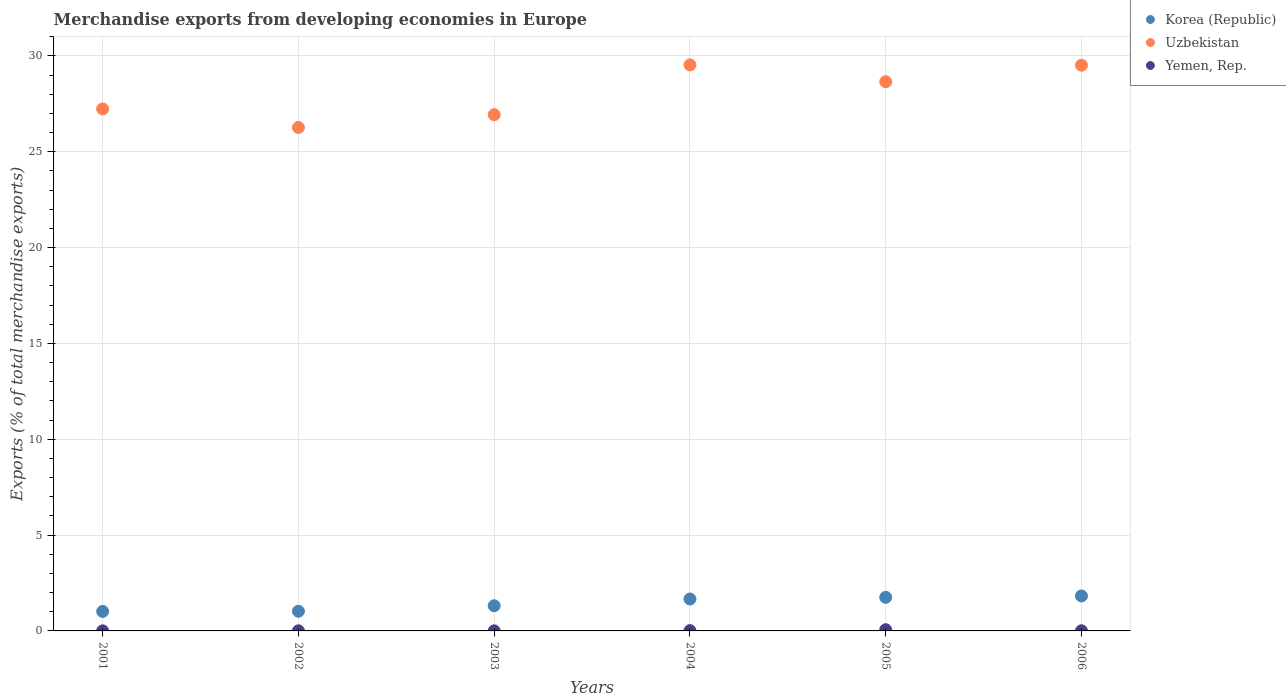How many different coloured dotlines are there?
Keep it short and to the point. 3. What is the percentage of total merchandise exports in Uzbekistan in 2004?
Offer a terse response. 29.53. Across all years, what is the maximum percentage of total merchandise exports in Korea (Republic)?
Provide a succinct answer. 1.82. Across all years, what is the minimum percentage of total merchandise exports in Yemen, Rep.?
Provide a short and direct response. 0. In which year was the percentage of total merchandise exports in Korea (Republic) maximum?
Ensure brevity in your answer.  2006. In which year was the percentage of total merchandise exports in Korea (Republic) minimum?
Offer a terse response. 2001. What is the total percentage of total merchandise exports in Korea (Republic) in the graph?
Keep it short and to the point. 8.6. What is the difference between the percentage of total merchandise exports in Uzbekistan in 2001 and that in 2006?
Offer a very short reply. -2.28. What is the difference between the percentage of total merchandise exports in Uzbekistan in 2004 and the percentage of total merchandise exports in Korea (Republic) in 2001?
Your response must be concise. 28.51. What is the average percentage of total merchandise exports in Korea (Republic) per year?
Your answer should be compact. 1.43. In the year 2002, what is the difference between the percentage of total merchandise exports in Yemen, Rep. and percentage of total merchandise exports in Uzbekistan?
Ensure brevity in your answer.  -26.26. In how many years, is the percentage of total merchandise exports in Uzbekistan greater than 11 %?
Your response must be concise. 6. What is the ratio of the percentage of total merchandise exports in Yemen, Rep. in 2003 to that in 2004?
Provide a short and direct response. 0.27. What is the difference between the highest and the second highest percentage of total merchandise exports in Yemen, Rep.?
Provide a short and direct response. 0.05. What is the difference between the highest and the lowest percentage of total merchandise exports in Uzbekistan?
Make the answer very short. 3.27. Is the sum of the percentage of total merchandise exports in Uzbekistan in 2005 and 2006 greater than the maximum percentage of total merchandise exports in Korea (Republic) across all years?
Give a very brief answer. Yes. Is it the case that in every year, the sum of the percentage of total merchandise exports in Korea (Republic) and percentage of total merchandise exports in Uzbekistan  is greater than the percentage of total merchandise exports in Yemen, Rep.?
Make the answer very short. Yes. Does the percentage of total merchandise exports in Yemen, Rep. monotonically increase over the years?
Your answer should be very brief. No. Is the percentage of total merchandise exports in Yemen, Rep. strictly greater than the percentage of total merchandise exports in Uzbekistan over the years?
Offer a very short reply. No. Is the percentage of total merchandise exports in Yemen, Rep. strictly less than the percentage of total merchandise exports in Uzbekistan over the years?
Offer a terse response. Yes. How many dotlines are there?
Provide a succinct answer. 3. How many years are there in the graph?
Offer a very short reply. 6. Are the values on the major ticks of Y-axis written in scientific E-notation?
Keep it short and to the point. No. Does the graph contain any zero values?
Offer a very short reply. No. What is the title of the graph?
Keep it short and to the point. Merchandise exports from developing economies in Europe. What is the label or title of the Y-axis?
Give a very brief answer. Exports (% of total merchandise exports). What is the Exports (% of total merchandise exports) in Korea (Republic) in 2001?
Make the answer very short. 1.02. What is the Exports (% of total merchandise exports) of Uzbekistan in 2001?
Your answer should be compact. 27.23. What is the Exports (% of total merchandise exports) of Yemen, Rep. in 2001?
Keep it short and to the point. 0. What is the Exports (% of total merchandise exports) of Korea (Republic) in 2002?
Provide a short and direct response. 1.03. What is the Exports (% of total merchandise exports) in Uzbekistan in 2002?
Make the answer very short. 26.26. What is the Exports (% of total merchandise exports) in Yemen, Rep. in 2002?
Provide a succinct answer. 0.01. What is the Exports (% of total merchandise exports) of Korea (Republic) in 2003?
Your answer should be very brief. 1.31. What is the Exports (% of total merchandise exports) of Uzbekistan in 2003?
Make the answer very short. 26.93. What is the Exports (% of total merchandise exports) in Yemen, Rep. in 2003?
Offer a very short reply. 0. What is the Exports (% of total merchandise exports) in Korea (Republic) in 2004?
Ensure brevity in your answer.  1.67. What is the Exports (% of total merchandise exports) of Uzbekistan in 2004?
Provide a short and direct response. 29.53. What is the Exports (% of total merchandise exports) in Yemen, Rep. in 2004?
Make the answer very short. 0.02. What is the Exports (% of total merchandise exports) in Korea (Republic) in 2005?
Make the answer very short. 1.75. What is the Exports (% of total merchandise exports) of Uzbekistan in 2005?
Offer a terse response. 28.65. What is the Exports (% of total merchandise exports) of Yemen, Rep. in 2005?
Keep it short and to the point. 0.06. What is the Exports (% of total merchandise exports) of Korea (Republic) in 2006?
Offer a terse response. 1.82. What is the Exports (% of total merchandise exports) of Uzbekistan in 2006?
Offer a terse response. 29.51. What is the Exports (% of total merchandise exports) of Yemen, Rep. in 2006?
Your answer should be compact. 0.01. Across all years, what is the maximum Exports (% of total merchandise exports) of Korea (Republic)?
Your answer should be very brief. 1.82. Across all years, what is the maximum Exports (% of total merchandise exports) in Uzbekistan?
Keep it short and to the point. 29.53. Across all years, what is the maximum Exports (% of total merchandise exports) in Yemen, Rep.?
Your answer should be very brief. 0.06. Across all years, what is the minimum Exports (% of total merchandise exports) of Korea (Republic)?
Keep it short and to the point. 1.02. Across all years, what is the minimum Exports (% of total merchandise exports) in Uzbekistan?
Your response must be concise. 26.26. Across all years, what is the minimum Exports (% of total merchandise exports) of Yemen, Rep.?
Provide a short and direct response. 0. What is the total Exports (% of total merchandise exports) of Korea (Republic) in the graph?
Make the answer very short. 8.6. What is the total Exports (% of total merchandise exports) in Uzbekistan in the graph?
Your response must be concise. 168.12. What is the total Exports (% of total merchandise exports) in Yemen, Rep. in the graph?
Ensure brevity in your answer.  0.1. What is the difference between the Exports (% of total merchandise exports) in Korea (Republic) in 2001 and that in 2002?
Ensure brevity in your answer.  -0.01. What is the difference between the Exports (% of total merchandise exports) of Uzbekistan in 2001 and that in 2002?
Offer a terse response. 0.97. What is the difference between the Exports (% of total merchandise exports) in Yemen, Rep. in 2001 and that in 2002?
Provide a short and direct response. -0. What is the difference between the Exports (% of total merchandise exports) in Korea (Republic) in 2001 and that in 2003?
Make the answer very short. -0.29. What is the difference between the Exports (% of total merchandise exports) in Uzbekistan in 2001 and that in 2003?
Your answer should be very brief. 0.3. What is the difference between the Exports (% of total merchandise exports) in Yemen, Rep. in 2001 and that in 2003?
Your answer should be very brief. -0. What is the difference between the Exports (% of total merchandise exports) of Korea (Republic) in 2001 and that in 2004?
Make the answer very short. -0.65. What is the difference between the Exports (% of total merchandise exports) in Uzbekistan in 2001 and that in 2004?
Your answer should be compact. -2.3. What is the difference between the Exports (% of total merchandise exports) of Yemen, Rep. in 2001 and that in 2004?
Offer a terse response. -0.01. What is the difference between the Exports (% of total merchandise exports) of Korea (Republic) in 2001 and that in 2005?
Keep it short and to the point. -0.73. What is the difference between the Exports (% of total merchandise exports) of Uzbekistan in 2001 and that in 2005?
Your answer should be very brief. -1.42. What is the difference between the Exports (% of total merchandise exports) in Yemen, Rep. in 2001 and that in 2005?
Your answer should be compact. -0.06. What is the difference between the Exports (% of total merchandise exports) of Korea (Republic) in 2001 and that in 2006?
Your answer should be very brief. -0.81. What is the difference between the Exports (% of total merchandise exports) in Uzbekistan in 2001 and that in 2006?
Offer a very short reply. -2.28. What is the difference between the Exports (% of total merchandise exports) in Yemen, Rep. in 2001 and that in 2006?
Your response must be concise. -0. What is the difference between the Exports (% of total merchandise exports) in Korea (Republic) in 2002 and that in 2003?
Provide a short and direct response. -0.29. What is the difference between the Exports (% of total merchandise exports) in Uzbekistan in 2002 and that in 2003?
Provide a succinct answer. -0.67. What is the difference between the Exports (% of total merchandise exports) in Yemen, Rep. in 2002 and that in 2003?
Make the answer very short. 0. What is the difference between the Exports (% of total merchandise exports) of Korea (Republic) in 2002 and that in 2004?
Offer a terse response. -0.64. What is the difference between the Exports (% of total merchandise exports) in Uzbekistan in 2002 and that in 2004?
Your answer should be compact. -3.27. What is the difference between the Exports (% of total merchandise exports) of Yemen, Rep. in 2002 and that in 2004?
Your response must be concise. -0.01. What is the difference between the Exports (% of total merchandise exports) in Korea (Republic) in 2002 and that in 2005?
Make the answer very short. -0.73. What is the difference between the Exports (% of total merchandise exports) of Uzbekistan in 2002 and that in 2005?
Keep it short and to the point. -2.39. What is the difference between the Exports (% of total merchandise exports) of Yemen, Rep. in 2002 and that in 2005?
Provide a succinct answer. -0.06. What is the difference between the Exports (% of total merchandise exports) of Korea (Republic) in 2002 and that in 2006?
Give a very brief answer. -0.8. What is the difference between the Exports (% of total merchandise exports) of Uzbekistan in 2002 and that in 2006?
Offer a very short reply. -3.25. What is the difference between the Exports (% of total merchandise exports) of Yemen, Rep. in 2002 and that in 2006?
Your response must be concise. -0. What is the difference between the Exports (% of total merchandise exports) of Korea (Republic) in 2003 and that in 2004?
Your answer should be compact. -0.35. What is the difference between the Exports (% of total merchandise exports) of Uzbekistan in 2003 and that in 2004?
Ensure brevity in your answer.  -2.6. What is the difference between the Exports (% of total merchandise exports) of Yemen, Rep. in 2003 and that in 2004?
Your answer should be very brief. -0.01. What is the difference between the Exports (% of total merchandise exports) in Korea (Republic) in 2003 and that in 2005?
Make the answer very short. -0.44. What is the difference between the Exports (% of total merchandise exports) in Uzbekistan in 2003 and that in 2005?
Offer a terse response. -1.72. What is the difference between the Exports (% of total merchandise exports) of Yemen, Rep. in 2003 and that in 2005?
Ensure brevity in your answer.  -0.06. What is the difference between the Exports (% of total merchandise exports) in Korea (Republic) in 2003 and that in 2006?
Provide a succinct answer. -0.51. What is the difference between the Exports (% of total merchandise exports) in Uzbekistan in 2003 and that in 2006?
Give a very brief answer. -2.58. What is the difference between the Exports (% of total merchandise exports) in Yemen, Rep. in 2003 and that in 2006?
Your response must be concise. -0. What is the difference between the Exports (% of total merchandise exports) in Korea (Republic) in 2004 and that in 2005?
Your answer should be compact. -0.09. What is the difference between the Exports (% of total merchandise exports) of Uzbekistan in 2004 and that in 2005?
Make the answer very short. 0.88. What is the difference between the Exports (% of total merchandise exports) of Yemen, Rep. in 2004 and that in 2005?
Make the answer very short. -0.05. What is the difference between the Exports (% of total merchandise exports) of Korea (Republic) in 2004 and that in 2006?
Keep it short and to the point. -0.16. What is the difference between the Exports (% of total merchandise exports) in Uzbekistan in 2004 and that in 2006?
Your response must be concise. 0.02. What is the difference between the Exports (% of total merchandise exports) in Yemen, Rep. in 2004 and that in 2006?
Make the answer very short. 0.01. What is the difference between the Exports (% of total merchandise exports) in Korea (Republic) in 2005 and that in 2006?
Your answer should be very brief. -0.07. What is the difference between the Exports (% of total merchandise exports) of Uzbekistan in 2005 and that in 2006?
Keep it short and to the point. -0.86. What is the difference between the Exports (% of total merchandise exports) in Yemen, Rep. in 2005 and that in 2006?
Make the answer very short. 0.05. What is the difference between the Exports (% of total merchandise exports) in Korea (Republic) in 2001 and the Exports (% of total merchandise exports) in Uzbekistan in 2002?
Your response must be concise. -25.25. What is the difference between the Exports (% of total merchandise exports) of Korea (Republic) in 2001 and the Exports (% of total merchandise exports) of Yemen, Rep. in 2002?
Keep it short and to the point. 1.01. What is the difference between the Exports (% of total merchandise exports) in Uzbekistan in 2001 and the Exports (% of total merchandise exports) in Yemen, Rep. in 2002?
Offer a very short reply. 27.23. What is the difference between the Exports (% of total merchandise exports) in Korea (Republic) in 2001 and the Exports (% of total merchandise exports) in Uzbekistan in 2003?
Your answer should be very brief. -25.91. What is the difference between the Exports (% of total merchandise exports) in Korea (Republic) in 2001 and the Exports (% of total merchandise exports) in Yemen, Rep. in 2003?
Your answer should be very brief. 1.01. What is the difference between the Exports (% of total merchandise exports) of Uzbekistan in 2001 and the Exports (% of total merchandise exports) of Yemen, Rep. in 2003?
Provide a short and direct response. 27.23. What is the difference between the Exports (% of total merchandise exports) of Korea (Republic) in 2001 and the Exports (% of total merchandise exports) of Uzbekistan in 2004?
Keep it short and to the point. -28.51. What is the difference between the Exports (% of total merchandise exports) of Korea (Republic) in 2001 and the Exports (% of total merchandise exports) of Yemen, Rep. in 2004?
Your response must be concise. 1. What is the difference between the Exports (% of total merchandise exports) of Uzbekistan in 2001 and the Exports (% of total merchandise exports) of Yemen, Rep. in 2004?
Your answer should be very brief. 27.22. What is the difference between the Exports (% of total merchandise exports) in Korea (Republic) in 2001 and the Exports (% of total merchandise exports) in Uzbekistan in 2005?
Keep it short and to the point. -27.63. What is the difference between the Exports (% of total merchandise exports) of Korea (Republic) in 2001 and the Exports (% of total merchandise exports) of Yemen, Rep. in 2005?
Give a very brief answer. 0.95. What is the difference between the Exports (% of total merchandise exports) in Uzbekistan in 2001 and the Exports (% of total merchandise exports) in Yemen, Rep. in 2005?
Offer a terse response. 27.17. What is the difference between the Exports (% of total merchandise exports) of Korea (Republic) in 2001 and the Exports (% of total merchandise exports) of Uzbekistan in 2006?
Ensure brevity in your answer.  -28.49. What is the difference between the Exports (% of total merchandise exports) in Korea (Republic) in 2001 and the Exports (% of total merchandise exports) in Yemen, Rep. in 2006?
Offer a very short reply. 1.01. What is the difference between the Exports (% of total merchandise exports) of Uzbekistan in 2001 and the Exports (% of total merchandise exports) of Yemen, Rep. in 2006?
Your answer should be very brief. 27.22. What is the difference between the Exports (% of total merchandise exports) in Korea (Republic) in 2002 and the Exports (% of total merchandise exports) in Uzbekistan in 2003?
Give a very brief answer. -25.9. What is the difference between the Exports (% of total merchandise exports) in Korea (Republic) in 2002 and the Exports (% of total merchandise exports) in Yemen, Rep. in 2003?
Your answer should be very brief. 1.02. What is the difference between the Exports (% of total merchandise exports) in Uzbekistan in 2002 and the Exports (% of total merchandise exports) in Yemen, Rep. in 2003?
Ensure brevity in your answer.  26.26. What is the difference between the Exports (% of total merchandise exports) in Korea (Republic) in 2002 and the Exports (% of total merchandise exports) in Uzbekistan in 2004?
Provide a short and direct response. -28.5. What is the difference between the Exports (% of total merchandise exports) in Korea (Republic) in 2002 and the Exports (% of total merchandise exports) in Yemen, Rep. in 2004?
Your response must be concise. 1.01. What is the difference between the Exports (% of total merchandise exports) in Uzbekistan in 2002 and the Exports (% of total merchandise exports) in Yemen, Rep. in 2004?
Provide a short and direct response. 26.25. What is the difference between the Exports (% of total merchandise exports) in Korea (Republic) in 2002 and the Exports (% of total merchandise exports) in Uzbekistan in 2005?
Offer a terse response. -27.63. What is the difference between the Exports (% of total merchandise exports) in Korea (Republic) in 2002 and the Exports (% of total merchandise exports) in Yemen, Rep. in 2005?
Give a very brief answer. 0.96. What is the difference between the Exports (% of total merchandise exports) of Uzbekistan in 2002 and the Exports (% of total merchandise exports) of Yemen, Rep. in 2005?
Your answer should be very brief. 26.2. What is the difference between the Exports (% of total merchandise exports) in Korea (Republic) in 2002 and the Exports (% of total merchandise exports) in Uzbekistan in 2006?
Your answer should be very brief. -28.49. What is the difference between the Exports (% of total merchandise exports) in Korea (Republic) in 2002 and the Exports (% of total merchandise exports) in Yemen, Rep. in 2006?
Your answer should be compact. 1.02. What is the difference between the Exports (% of total merchandise exports) in Uzbekistan in 2002 and the Exports (% of total merchandise exports) in Yemen, Rep. in 2006?
Ensure brevity in your answer.  26.26. What is the difference between the Exports (% of total merchandise exports) of Korea (Republic) in 2003 and the Exports (% of total merchandise exports) of Uzbekistan in 2004?
Your answer should be compact. -28.22. What is the difference between the Exports (% of total merchandise exports) of Korea (Republic) in 2003 and the Exports (% of total merchandise exports) of Yemen, Rep. in 2004?
Your response must be concise. 1.3. What is the difference between the Exports (% of total merchandise exports) of Uzbekistan in 2003 and the Exports (% of total merchandise exports) of Yemen, Rep. in 2004?
Offer a terse response. 26.91. What is the difference between the Exports (% of total merchandise exports) of Korea (Republic) in 2003 and the Exports (% of total merchandise exports) of Uzbekistan in 2005?
Your answer should be compact. -27.34. What is the difference between the Exports (% of total merchandise exports) of Uzbekistan in 2003 and the Exports (% of total merchandise exports) of Yemen, Rep. in 2005?
Your answer should be very brief. 26.87. What is the difference between the Exports (% of total merchandise exports) of Korea (Republic) in 2003 and the Exports (% of total merchandise exports) of Uzbekistan in 2006?
Your response must be concise. -28.2. What is the difference between the Exports (% of total merchandise exports) of Korea (Republic) in 2003 and the Exports (% of total merchandise exports) of Yemen, Rep. in 2006?
Keep it short and to the point. 1.3. What is the difference between the Exports (% of total merchandise exports) of Uzbekistan in 2003 and the Exports (% of total merchandise exports) of Yemen, Rep. in 2006?
Ensure brevity in your answer.  26.92. What is the difference between the Exports (% of total merchandise exports) of Korea (Republic) in 2004 and the Exports (% of total merchandise exports) of Uzbekistan in 2005?
Your answer should be very brief. -26.99. What is the difference between the Exports (% of total merchandise exports) in Korea (Republic) in 2004 and the Exports (% of total merchandise exports) in Yemen, Rep. in 2005?
Your answer should be very brief. 1.6. What is the difference between the Exports (% of total merchandise exports) of Uzbekistan in 2004 and the Exports (% of total merchandise exports) of Yemen, Rep. in 2005?
Provide a succinct answer. 29.47. What is the difference between the Exports (% of total merchandise exports) of Korea (Republic) in 2004 and the Exports (% of total merchandise exports) of Uzbekistan in 2006?
Offer a terse response. -27.85. What is the difference between the Exports (% of total merchandise exports) of Korea (Republic) in 2004 and the Exports (% of total merchandise exports) of Yemen, Rep. in 2006?
Provide a succinct answer. 1.66. What is the difference between the Exports (% of total merchandise exports) of Uzbekistan in 2004 and the Exports (% of total merchandise exports) of Yemen, Rep. in 2006?
Provide a succinct answer. 29.52. What is the difference between the Exports (% of total merchandise exports) of Korea (Republic) in 2005 and the Exports (% of total merchandise exports) of Uzbekistan in 2006?
Keep it short and to the point. -27.76. What is the difference between the Exports (% of total merchandise exports) of Korea (Republic) in 2005 and the Exports (% of total merchandise exports) of Yemen, Rep. in 2006?
Your response must be concise. 1.74. What is the difference between the Exports (% of total merchandise exports) in Uzbekistan in 2005 and the Exports (% of total merchandise exports) in Yemen, Rep. in 2006?
Give a very brief answer. 28.64. What is the average Exports (% of total merchandise exports) of Korea (Republic) per year?
Provide a succinct answer. 1.43. What is the average Exports (% of total merchandise exports) in Uzbekistan per year?
Ensure brevity in your answer.  28.02. What is the average Exports (% of total merchandise exports) of Yemen, Rep. per year?
Offer a terse response. 0.02. In the year 2001, what is the difference between the Exports (% of total merchandise exports) of Korea (Republic) and Exports (% of total merchandise exports) of Uzbekistan?
Give a very brief answer. -26.21. In the year 2001, what is the difference between the Exports (% of total merchandise exports) in Korea (Republic) and Exports (% of total merchandise exports) in Yemen, Rep.?
Your answer should be compact. 1.01. In the year 2001, what is the difference between the Exports (% of total merchandise exports) of Uzbekistan and Exports (% of total merchandise exports) of Yemen, Rep.?
Ensure brevity in your answer.  27.23. In the year 2002, what is the difference between the Exports (% of total merchandise exports) in Korea (Republic) and Exports (% of total merchandise exports) in Uzbekistan?
Make the answer very short. -25.24. In the year 2002, what is the difference between the Exports (% of total merchandise exports) in Uzbekistan and Exports (% of total merchandise exports) in Yemen, Rep.?
Make the answer very short. 26.26. In the year 2003, what is the difference between the Exports (% of total merchandise exports) in Korea (Republic) and Exports (% of total merchandise exports) in Uzbekistan?
Offer a terse response. -25.62. In the year 2003, what is the difference between the Exports (% of total merchandise exports) in Korea (Republic) and Exports (% of total merchandise exports) in Yemen, Rep.?
Provide a short and direct response. 1.31. In the year 2003, what is the difference between the Exports (% of total merchandise exports) in Uzbekistan and Exports (% of total merchandise exports) in Yemen, Rep.?
Give a very brief answer. 26.93. In the year 2004, what is the difference between the Exports (% of total merchandise exports) of Korea (Republic) and Exports (% of total merchandise exports) of Uzbekistan?
Offer a terse response. -27.86. In the year 2004, what is the difference between the Exports (% of total merchandise exports) of Korea (Republic) and Exports (% of total merchandise exports) of Yemen, Rep.?
Provide a short and direct response. 1.65. In the year 2004, what is the difference between the Exports (% of total merchandise exports) of Uzbekistan and Exports (% of total merchandise exports) of Yemen, Rep.?
Keep it short and to the point. 29.51. In the year 2005, what is the difference between the Exports (% of total merchandise exports) of Korea (Republic) and Exports (% of total merchandise exports) of Uzbekistan?
Keep it short and to the point. -26.9. In the year 2005, what is the difference between the Exports (% of total merchandise exports) of Korea (Republic) and Exports (% of total merchandise exports) of Yemen, Rep.?
Ensure brevity in your answer.  1.69. In the year 2005, what is the difference between the Exports (% of total merchandise exports) in Uzbekistan and Exports (% of total merchandise exports) in Yemen, Rep.?
Offer a terse response. 28.59. In the year 2006, what is the difference between the Exports (% of total merchandise exports) in Korea (Republic) and Exports (% of total merchandise exports) in Uzbekistan?
Provide a succinct answer. -27.69. In the year 2006, what is the difference between the Exports (% of total merchandise exports) in Korea (Republic) and Exports (% of total merchandise exports) in Yemen, Rep.?
Keep it short and to the point. 1.82. In the year 2006, what is the difference between the Exports (% of total merchandise exports) of Uzbekistan and Exports (% of total merchandise exports) of Yemen, Rep.?
Keep it short and to the point. 29.5. What is the ratio of the Exports (% of total merchandise exports) in Korea (Republic) in 2001 to that in 2002?
Your response must be concise. 0.99. What is the ratio of the Exports (% of total merchandise exports) of Uzbekistan in 2001 to that in 2002?
Ensure brevity in your answer.  1.04. What is the ratio of the Exports (% of total merchandise exports) in Yemen, Rep. in 2001 to that in 2002?
Provide a short and direct response. 0.68. What is the ratio of the Exports (% of total merchandise exports) in Korea (Republic) in 2001 to that in 2003?
Offer a terse response. 0.78. What is the ratio of the Exports (% of total merchandise exports) in Uzbekistan in 2001 to that in 2003?
Your answer should be very brief. 1.01. What is the ratio of the Exports (% of total merchandise exports) in Yemen, Rep. in 2001 to that in 2003?
Make the answer very short. 0.92. What is the ratio of the Exports (% of total merchandise exports) of Korea (Republic) in 2001 to that in 2004?
Ensure brevity in your answer.  0.61. What is the ratio of the Exports (% of total merchandise exports) in Uzbekistan in 2001 to that in 2004?
Provide a short and direct response. 0.92. What is the ratio of the Exports (% of total merchandise exports) of Yemen, Rep. in 2001 to that in 2004?
Give a very brief answer. 0.25. What is the ratio of the Exports (% of total merchandise exports) in Korea (Republic) in 2001 to that in 2005?
Provide a succinct answer. 0.58. What is the ratio of the Exports (% of total merchandise exports) in Uzbekistan in 2001 to that in 2005?
Your answer should be very brief. 0.95. What is the ratio of the Exports (% of total merchandise exports) of Yemen, Rep. in 2001 to that in 2005?
Your answer should be compact. 0.06. What is the ratio of the Exports (% of total merchandise exports) of Korea (Republic) in 2001 to that in 2006?
Provide a succinct answer. 0.56. What is the ratio of the Exports (% of total merchandise exports) of Uzbekistan in 2001 to that in 2006?
Provide a succinct answer. 0.92. What is the ratio of the Exports (% of total merchandise exports) in Yemen, Rep. in 2001 to that in 2006?
Your answer should be very brief. 0.49. What is the ratio of the Exports (% of total merchandise exports) of Korea (Republic) in 2002 to that in 2003?
Your answer should be very brief. 0.78. What is the ratio of the Exports (% of total merchandise exports) of Uzbekistan in 2002 to that in 2003?
Keep it short and to the point. 0.98. What is the ratio of the Exports (% of total merchandise exports) of Yemen, Rep. in 2002 to that in 2003?
Give a very brief answer. 1.35. What is the ratio of the Exports (% of total merchandise exports) in Korea (Republic) in 2002 to that in 2004?
Your answer should be compact. 0.62. What is the ratio of the Exports (% of total merchandise exports) of Uzbekistan in 2002 to that in 2004?
Your response must be concise. 0.89. What is the ratio of the Exports (% of total merchandise exports) in Yemen, Rep. in 2002 to that in 2004?
Keep it short and to the point. 0.36. What is the ratio of the Exports (% of total merchandise exports) in Korea (Republic) in 2002 to that in 2005?
Offer a terse response. 0.59. What is the ratio of the Exports (% of total merchandise exports) in Yemen, Rep. in 2002 to that in 2005?
Provide a succinct answer. 0.09. What is the ratio of the Exports (% of total merchandise exports) of Korea (Republic) in 2002 to that in 2006?
Offer a terse response. 0.56. What is the ratio of the Exports (% of total merchandise exports) of Uzbekistan in 2002 to that in 2006?
Your answer should be very brief. 0.89. What is the ratio of the Exports (% of total merchandise exports) of Yemen, Rep. in 2002 to that in 2006?
Provide a succinct answer. 0.72. What is the ratio of the Exports (% of total merchandise exports) of Korea (Republic) in 2003 to that in 2004?
Provide a succinct answer. 0.79. What is the ratio of the Exports (% of total merchandise exports) of Uzbekistan in 2003 to that in 2004?
Your response must be concise. 0.91. What is the ratio of the Exports (% of total merchandise exports) of Yemen, Rep. in 2003 to that in 2004?
Your answer should be very brief. 0.27. What is the ratio of the Exports (% of total merchandise exports) in Korea (Republic) in 2003 to that in 2005?
Provide a short and direct response. 0.75. What is the ratio of the Exports (% of total merchandise exports) of Uzbekistan in 2003 to that in 2005?
Make the answer very short. 0.94. What is the ratio of the Exports (% of total merchandise exports) in Yemen, Rep. in 2003 to that in 2005?
Your answer should be compact. 0.07. What is the ratio of the Exports (% of total merchandise exports) in Korea (Republic) in 2003 to that in 2006?
Offer a very short reply. 0.72. What is the ratio of the Exports (% of total merchandise exports) in Uzbekistan in 2003 to that in 2006?
Your answer should be compact. 0.91. What is the ratio of the Exports (% of total merchandise exports) of Yemen, Rep. in 2003 to that in 2006?
Ensure brevity in your answer.  0.53. What is the ratio of the Exports (% of total merchandise exports) of Korea (Republic) in 2004 to that in 2005?
Your response must be concise. 0.95. What is the ratio of the Exports (% of total merchandise exports) in Uzbekistan in 2004 to that in 2005?
Make the answer very short. 1.03. What is the ratio of the Exports (% of total merchandise exports) of Yemen, Rep. in 2004 to that in 2005?
Provide a short and direct response. 0.26. What is the ratio of the Exports (% of total merchandise exports) of Korea (Republic) in 2004 to that in 2006?
Make the answer very short. 0.91. What is the ratio of the Exports (% of total merchandise exports) of Uzbekistan in 2004 to that in 2006?
Offer a very short reply. 1. What is the ratio of the Exports (% of total merchandise exports) of Yemen, Rep. in 2004 to that in 2006?
Provide a short and direct response. 1.99. What is the ratio of the Exports (% of total merchandise exports) of Korea (Republic) in 2005 to that in 2006?
Provide a short and direct response. 0.96. What is the ratio of the Exports (% of total merchandise exports) of Uzbekistan in 2005 to that in 2006?
Offer a terse response. 0.97. What is the ratio of the Exports (% of total merchandise exports) in Yemen, Rep. in 2005 to that in 2006?
Your answer should be compact. 7.65. What is the difference between the highest and the second highest Exports (% of total merchandise exports) in Korea (Republic)?
Your answer should be very brief. 0.07. What is the difference between the highest and the second highest Exports (% of total merchandise exports) of Uzbekistan?
Ensure brevity in your answer.  0.02. What is the difference between the highest and the second highest Exports (% of total merchandise exports) of Yemen, Rep.?
Provide a succinct answer. 0.05. What is the difference between the highest and the lowest Exports (% of total merchandise exports) in Korea (Republic)?
Your answer should be very brief. 0.81. What is the difference between the highest and the lowest Exports (% of total merchandise exports) of Uzbekistan?
Offer a very short reply. 3.27. What is the difference between the highest and the lowest Exports (% of total merchandise exports) in Yemen, Rep.?
Your answer should be very brief. 0.06. 